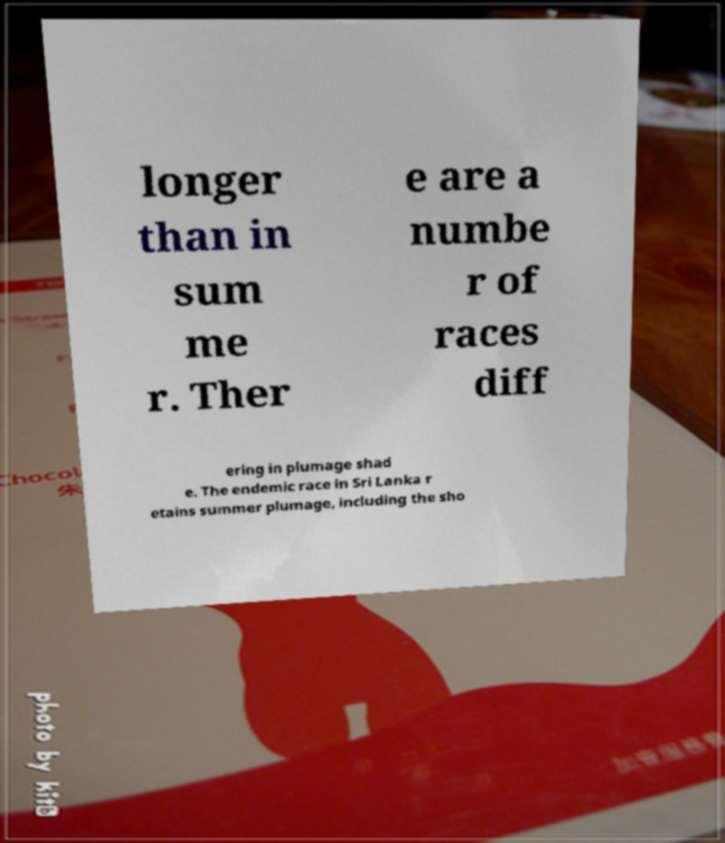Can you read and provide the text displayed in the image?This photo seems to have some interesting text. Can you extract and type it out for me? longer than in sum me r. Ther e are a numbe r of races diff ering in plumage shad e. The endemic race in Sri Lanka r etains summer plumage, including the sho 